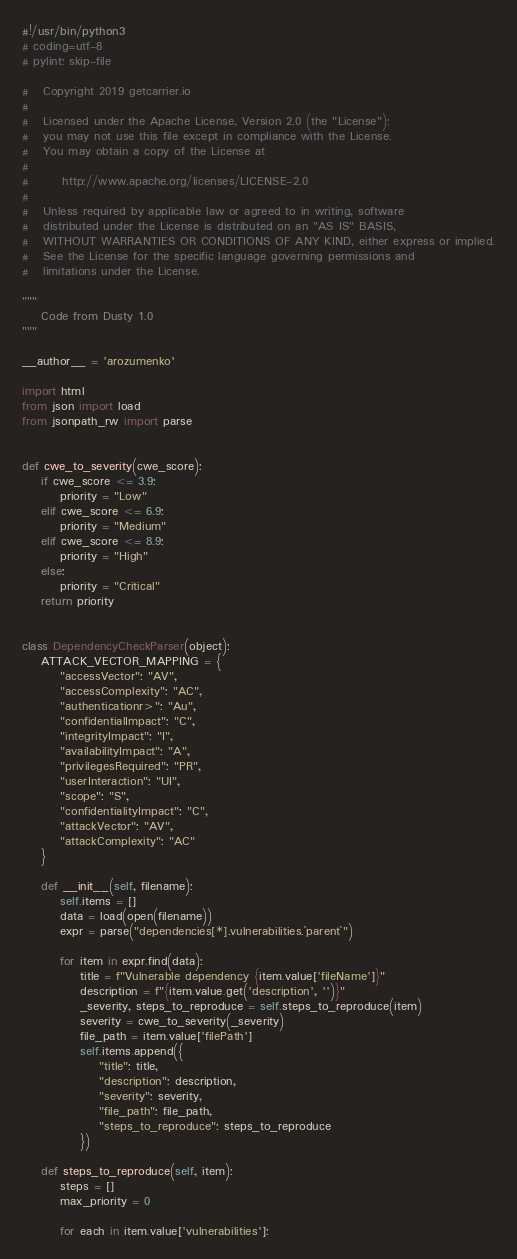Convert code to text. <code><loc_0><loc_0><loc_500><loc_500><_Python_>#!/usr/bin/python3
# coding=utf-8
# pylint: skip-file

#   Copyright 2019 getcarrier.io
#
#   Licensed under the Apache License, Version 2.0 (the "License");
#   you may not use this file except in compliance with the License.
#   You may obtain a copy of the License at
#
#       http://www.apache.org/licenses/LICENSE-2.0
#
#   Unless required by applicable law or agreed to in writing, software
#   distributed under the License is distributed on an "AS IS" BASIS,
#   WITHOUT WARRANTIES OR CONDITIONS OF ANY KIND, either express or implied.
#   See the License for the specific language governing permissions and
#   limitations under the License.

"""
    Code from Dusty 1.0
"""

__author__ = 'arozumenko'

import html
from json import load
from jsonpath_rw import parse


def cwe_to_severity(cwe_score):
    if cwe_score <= 3.9:
        priority = "Low"
    elif cwe_score <= 6.9:
        priority = "Medium"
    elif cwe_score <= 8.9:
        priority = "High"
    else:
        priority = "Critical"
    return priority


class DependencyCheckParser(object):
    ATTACK_VECTOR_MAPPING = {
        "accessVector": "AV",
        "accessComplexity": "AC",
        "authenticationr>": "Au",
        "confidentialImpact": "C",
        "integrityImpact": "I",
        "availabilityImpact": "A",
        "privilegesRequired": "PR",
        "userInteraction": "UI",
        "scope": "S",
        "confidentialityImpact": "C",
        "attackVector": "AV",
        "attackComplexity": "AC"
    }

    def __init__(self, filename):
        self.items = []
        data = load(open(filename))
        expr = parse("dependencies[*].vulnerabilities.`parent`")

        for item in expr.find(data):
            title = f"Vulnerable dependency {item.value['fileName']}"
            description = f"{item.value.get('description', '')}"
            _severity, steps_to_reproduce = self.steps_to_reproduce(item)
            severity = cwe_to_severity(_severity)
            file_path = item.value['filePath']
            self.items.append({
                "title": title,
                "description": description,
                "severity": severity,
                "file_path": file_path,
                "steps_to_reproduce": steps_to_reproduce
            })

    def steps_to_reproduce(self, item):
        steps = []
        max_priority = 0

        for each in item.value['vulnerabilities']:</code> 